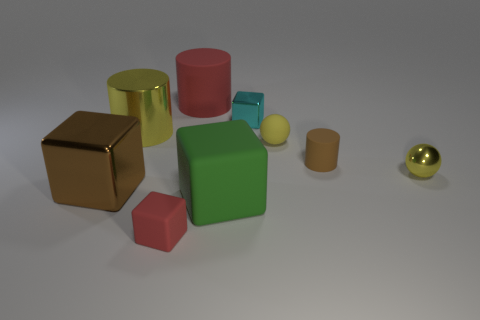Subtract 2 cubes. How many cubes are left? 2 Subtract all cyan cubes. How many cubes are left? 3 Subtract all purple blocks. Subtract all yellow cylinders. How many blocks are left? 4 Subtract all small cyan cylinders. Subtract all red things. How many objects are left? 7 Add 2 large red rubber objects. How many large red rubber objects are left? 3 Add 9 small blue shiny things. How many small blue shiny things exist? 9 Subtract 0 cyan balls. How many objects are left? 9 Subtract all spheres. How many objects are left? 7 